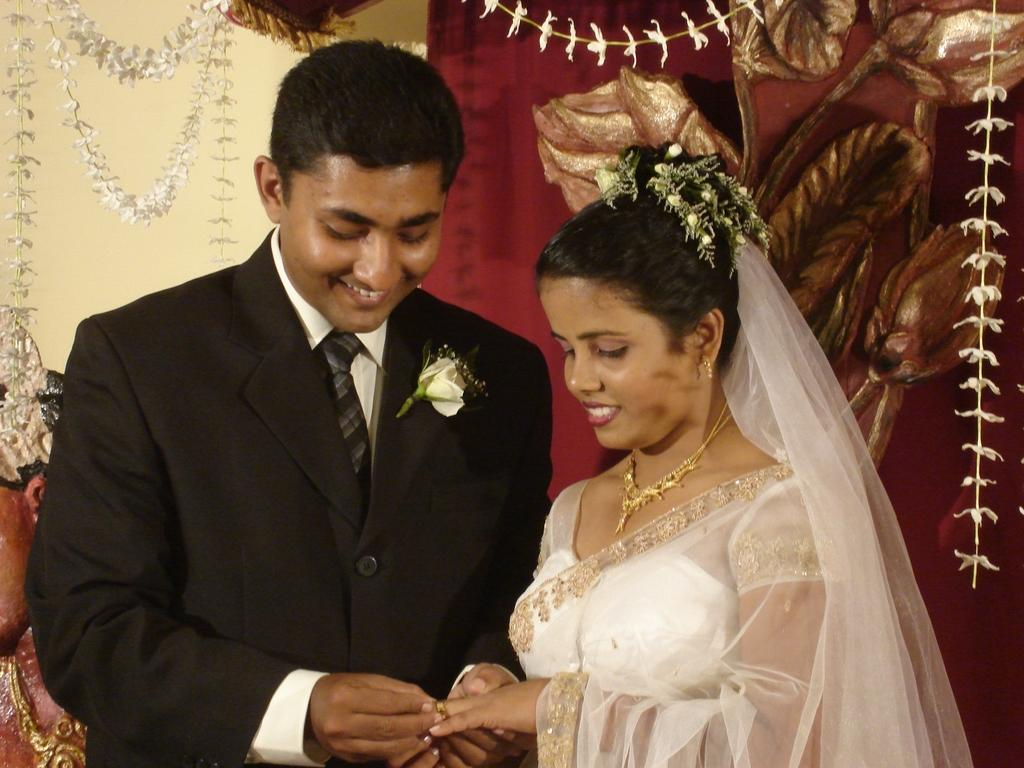How many people are in the image? There are two people in the image. What are the people wearing? Both people are wearing black and white color dresses. What can be seen in the background of the image? There are decorative items visible in the background. What is the color scheme of the background? The background has a red and cream color scheme. What type of vest is the person on the left wearing in the image? There is no vest visible on either person in the image; they are both wearing black and white color dresses. 